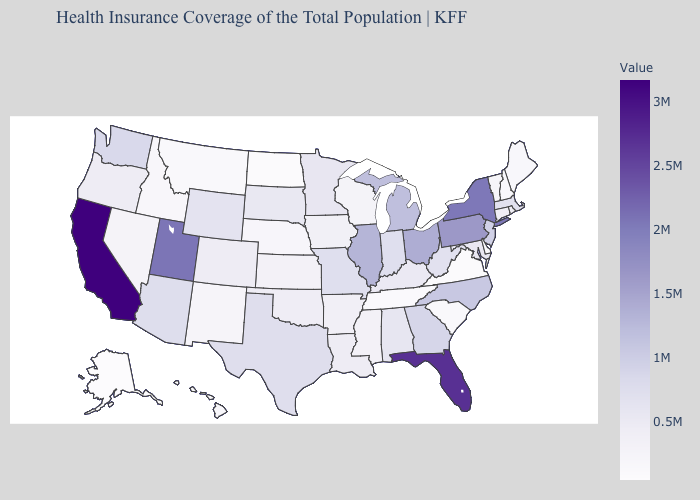Which states hav the highest value in the South?
Be succinct. Florida. Does Oklahoma have the lowest value in the South?
Give a very brief answer. No. Does Washington have a lower value than Florida?
Be succinct. Yes. Which states have the highest value in the USA?
Concise answer only. California. Which states have the lowest value in the South?
Concise answer only. Virginia. 